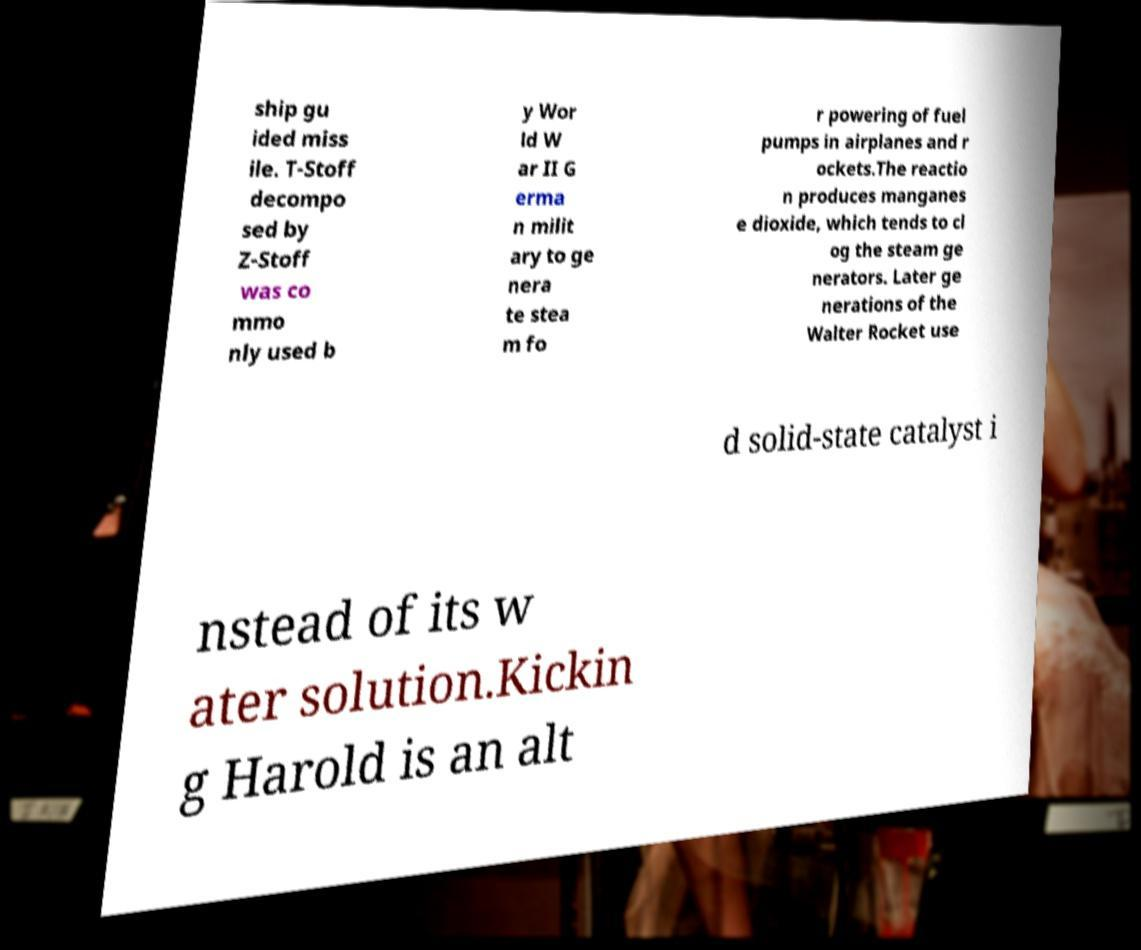For documentation purposes, I need the text within this image transcribed. Could you provide that? ship gu ided miss ile. T-Stoff decompo sed by Z-Stoff was co mmo nly used b y Wor ld W ar II G erma n milit ary to ge nera te stea m fo r powering of fuel pumps in airplanes and r ockets.The reactio n produces manganes e dioxide, which tends to cl og the steam ge nerators. Later ge nerations of the Walter Rocket use d solid-state catalyst i nstead of its w ater solution.Kickin g Harold is an alt 